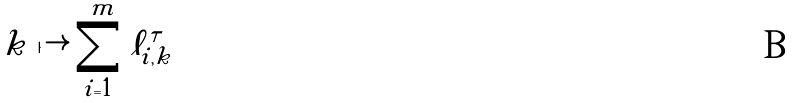<formula> <loc_0><loc_0><loc_500><loc_500>k \mapsto \sum _ { i = 1 } ^ { m } \ell _ { i , k } ^ { \tau }</formula> 